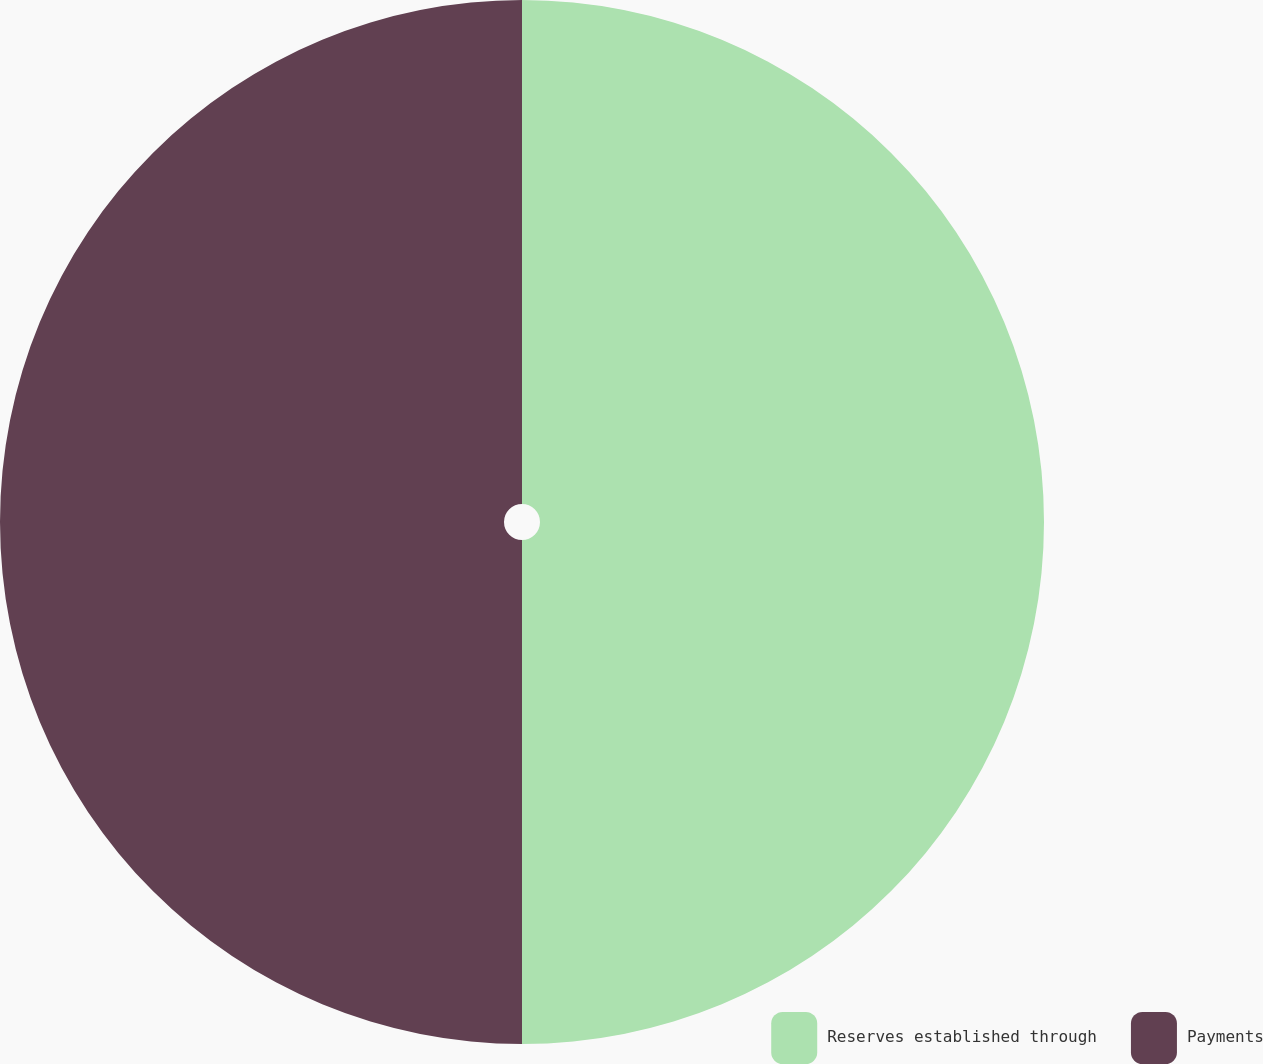Convert chart. <chart><loc_0><loc_0><loc_500><loc_500><pie_chart><fcel>Reserves established through<fcel>Payments<nl><fcel>50.0%<fcel>50.0%<nl></chart> 